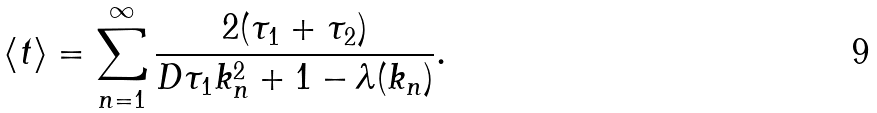<formula> <loc_0><loc_0><loc_500><loc_500>\left < t \right > = \sum _ { n = 1 } ^ { \infty } \frac { 2 ( \tau _ { 1 } + \tau _ { 2 } ) } { D \tau _ { 1 } k _ { n } ^ { 2 } + 1 - \lambda ( k _ { n } ) } .</formula> 